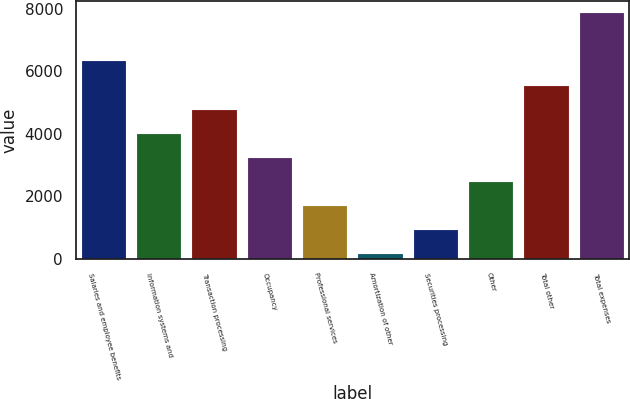<chart> <loc_0><loc_0><loc_500><loc_500><bar_chart><fcel>Salaries and employee benefits<fcel>Information systems and<fcel>Transaction processing<fcel>Occupancy<fcel>Professional services<fcel>Amortization of other<fcel>Securities processing<fcel>Other<fcel>Total other<fcel>Total expenses<nl><fcel>6309.6<fcel>3997.5<fcel>4768.2<fcel>3226.8<fcel>1685.4<fcel>144<fcel>914.7<fcel>2456.1<fcel>5538.9<fcel>7851<nl></chart> 